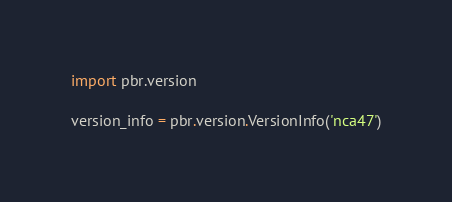<code> <loc_0><loc_0><loc_500><loc_500><_Python_>import pbr.version

version_info = pbr.version.VersionInfo('nca47')
</code> 